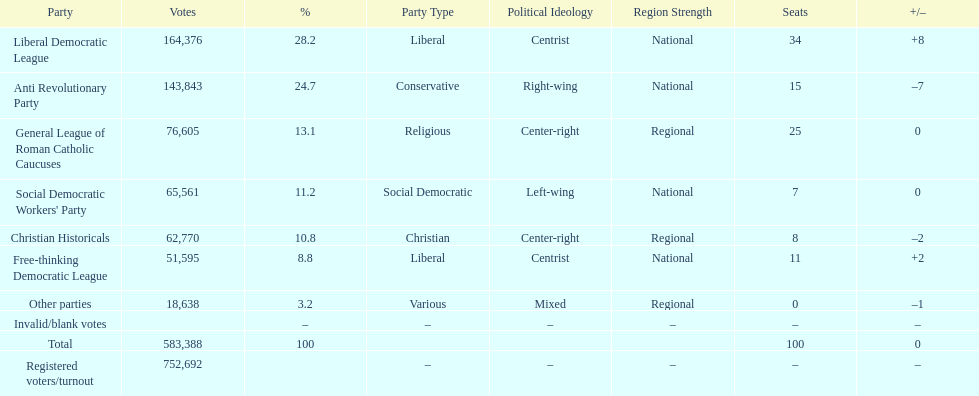How many votes were counted as invalid or blank votes? 0. 